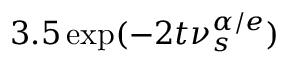Convert formula to latex. <formula><loc_0><loc_0><loc_500><loc_500>3 . 5 \exp ( - 2 t \nu _ { s } ^ { \alpha / e } )</formula> 